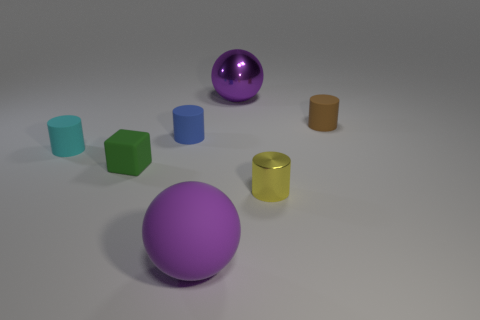Does the small green cube have the same material as the large object that is behind the small yellow object?
Provide a short and direct response. No. Is the number of matte cylinders that are to the right of the metallic cylinder greater than the number of green blocks?
Ensure brevity in your answer.  No. Is there a small cyan ball that has the same material as the cube?
Your answer should be compact. No. Are the purple thing in front of the tiny blue matte thing and the big purple thing behind the tiny blue matte object made of the same material?
Give a very brief answer. No. Are there the same number of small things that are in front of the brown cylinder and matte objects that are on the left side of the tiny green matte object?
Your answer should be compact. No. There is a matte block that is the same size as the brown object; what is its color?
Ensure brevity in your answer.  Green. Are there any other tiny matte blocks of the same color as the small cube?
Keep it short and to the point. No. What number of things are tiny rubber objects that are to the right of the tiny cyan thing or big yellow metallic cubes?
Offer a terse response. 3. What number of other objects are the same size as the cyan matte object?
Your answer should be compact. 4. The big purple object behind the matte thing that is right of the purple ball that is in front of the blue cylinder is made of what material?
Your response must be concise. Metal. 